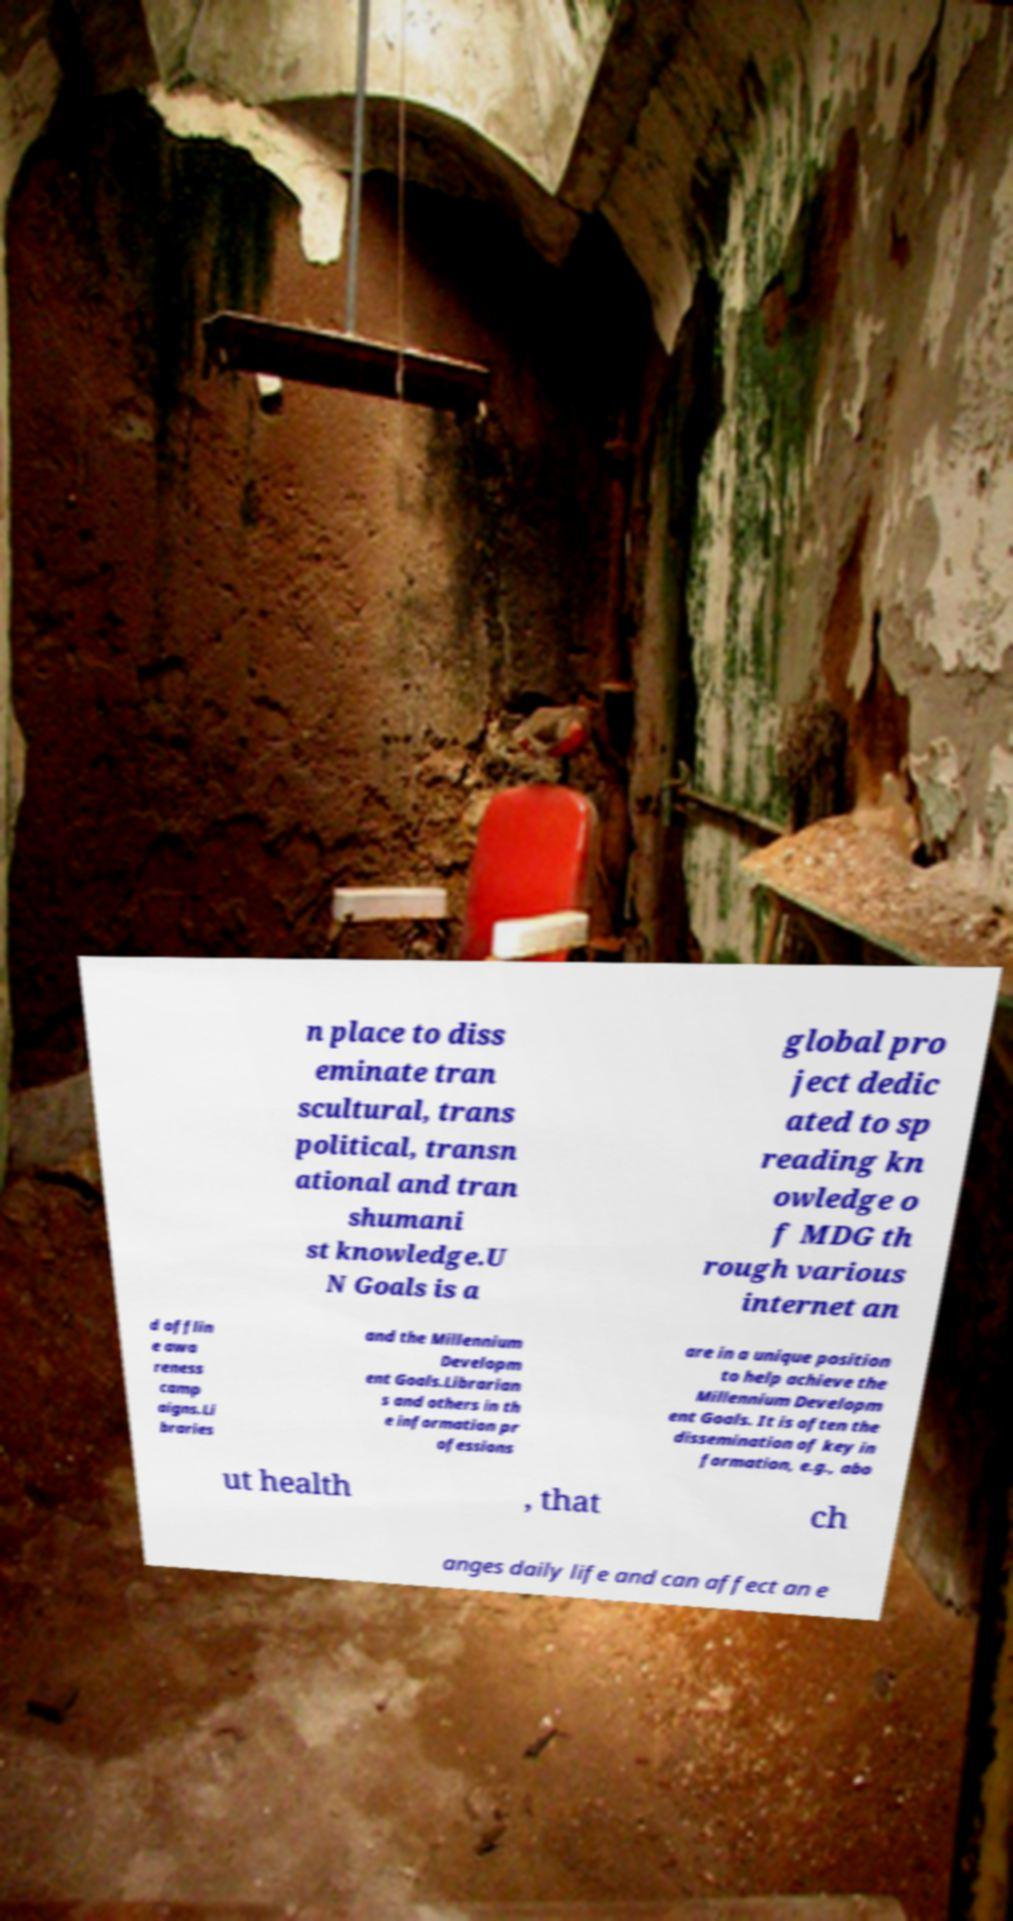Please read and relay the text visible in this image. What does it say? n place to diss eminate tran scultural, trans political, transn ational and tran shumani st knowledge.U N Goals is a global pro ject dedic ated to sp reading kn owledge o f MDG th rough various internet an d offlin e awa reness camp aigns.Li braries and the Millennium Developm ent Goals.Librarian s and others in th e information pr ofessions are in a unique position to help achieve the Millennium Developm ent Goals. It is often the dissemination of key in formation, e.g., abo ut health , that ch anges daily life and can affect an e 